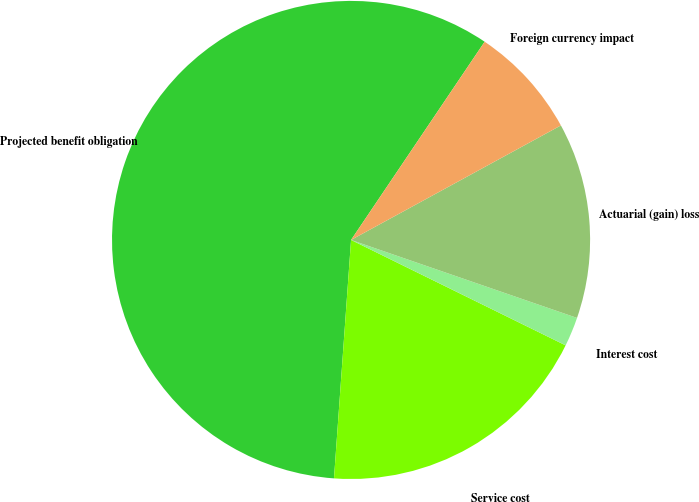Convert chart. <chart><loc_0><loc_0><loc_500><loc_500><pie_chart><fcel>Projected benefit obligation<fcel>Service cost<fcel>Interest cost<fcel>Actuarial (gain) loss<fcel>Foreign currency impact<nl><fcel>58.3%<fcel>18.87%<fcel>1.98%<fcel>13.24%<fcel>7.61%<nl></chart> 